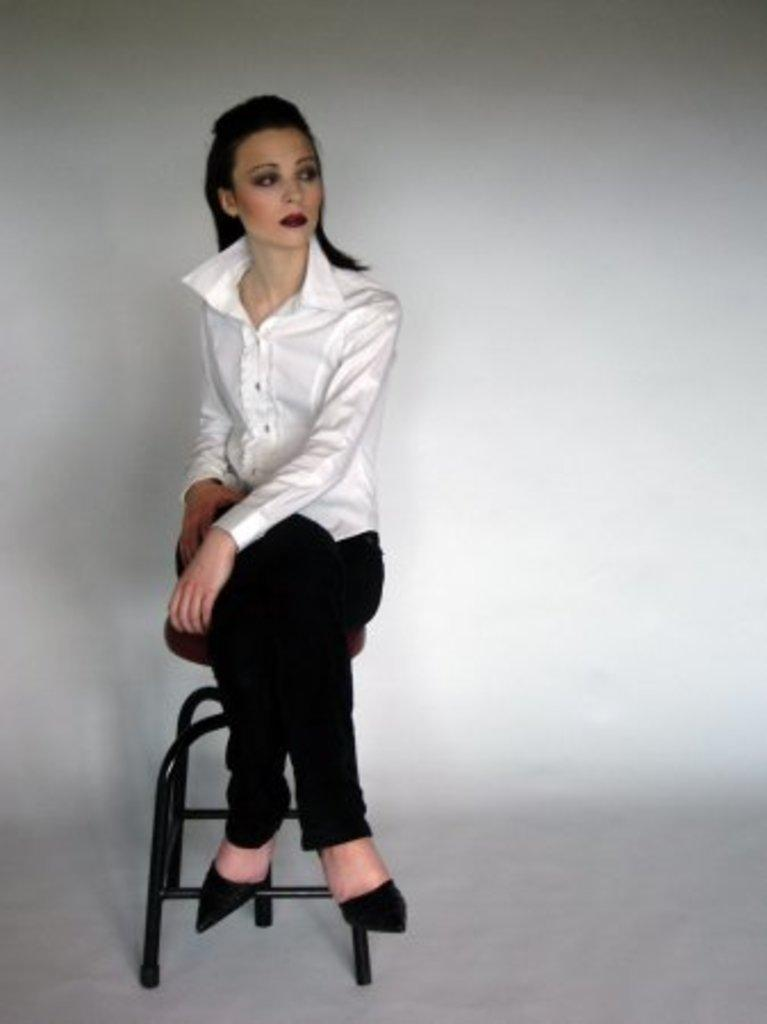What is the main subject of the image? There is a person in the image. What is the person doing in the image? The person is sitting on a chair. What type of coast can be seen in the image? There is no coast present in the image; it features a person sitting on a chair. What type of drink is the governor holding in the image? There is no drink or governor present in the image. 